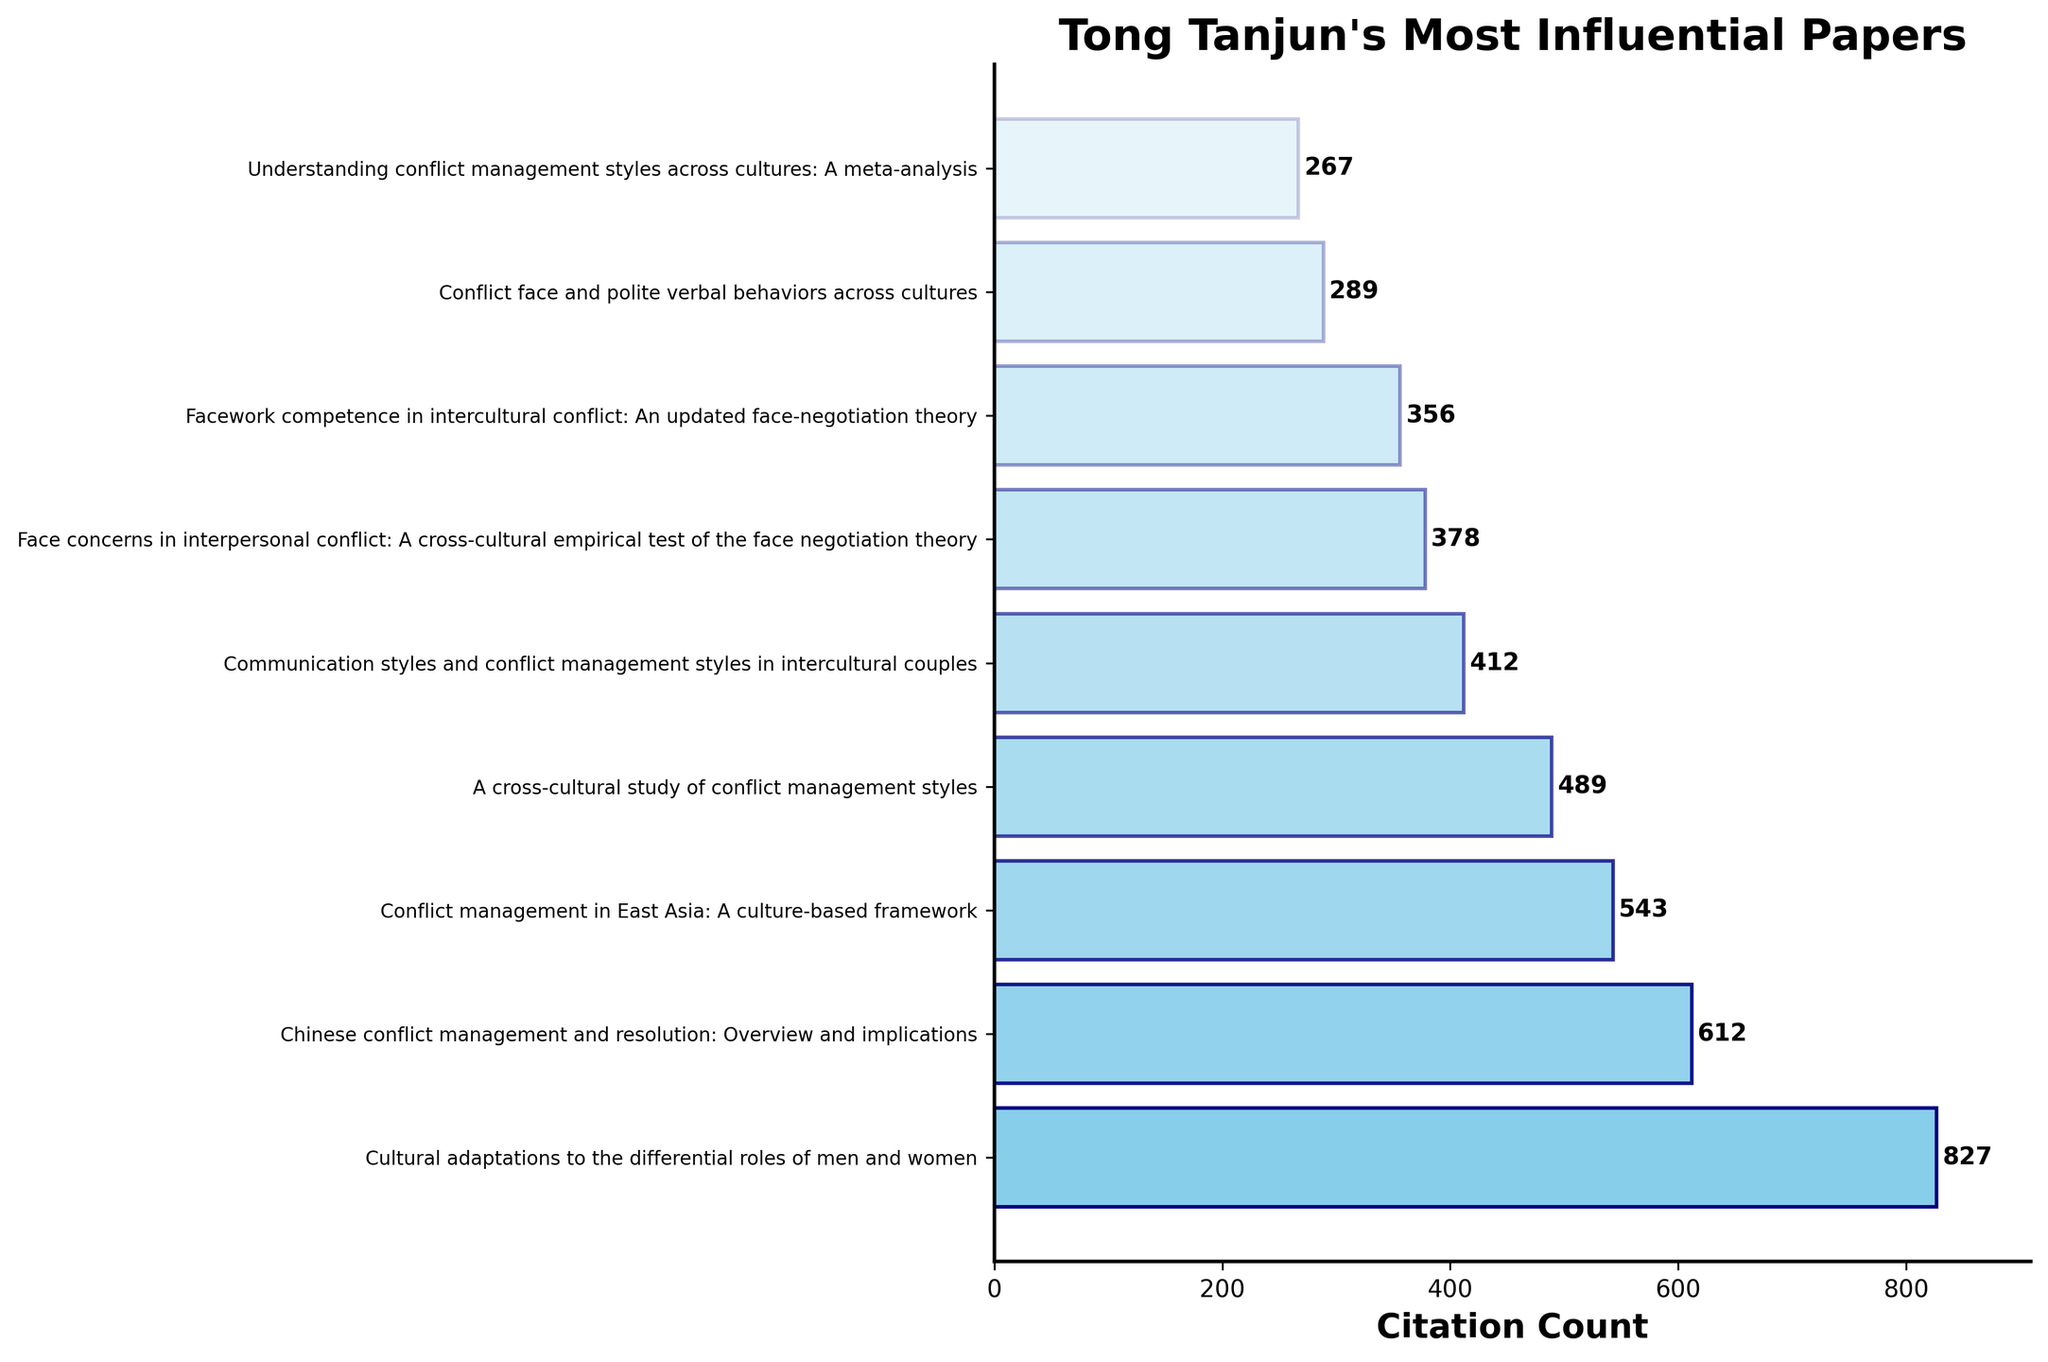What's the title of the paper with the highest citation count? The highest bar in the plot corresponds to the paper titled "Cultural adaptations to the differential roles of men and women," which has the longest horizontal length
Answer: Cultural adaptations to the differential roles of men and women How many citations does the paper with the second-highest citation count have? The second highest bar indicates the paper titled "Chinese conflict management and resolution: Overview and implications," and the number at the end of its bar reads 612
Answer: 612 What is the total citation count of the three most cited papers? The sum of the citations of the top three papers is 827 (first) + 612 (second) + 543 (third) = 1982
Answer: 1982 Which paper has slightly fewer citations than "A cross-cultural study of conflict management styles"? By looking at the bars, "Communication styles and conflict management styles in intercultural couples" has slightly fewer citations than "A cross-cultural study of conflict management styles," with 412 compared to 489
Answer: Communication styles and conflict management styles in intercultural couples What is the difference in citation counts between the papers with the highest and lowest citations? The highest citation count is 827, and the lowest is 267, so the difference is 827 - 267 = 560
Answer: 560 What is the average citation count for all the papers? Sum all citations (827 + 612 + 543 + 489 + 412 + 378 + 356 + 289 + 267) to get 4173. There are 9 papers, so the average is 4173 / 9 ≈ 463.67
Answer: 463.67 How many papers have a citation count greater than 400? Five bars on the chart have citations above 400: the top five papers in the list
Answer: 5 What is the median citation count for these papers? Arrange the papers' citations in ascending order: 267, 289, 356, 378, 412, 489, 543, 612, 827. The middle value (fifth paper) is 412
Answer: 412 